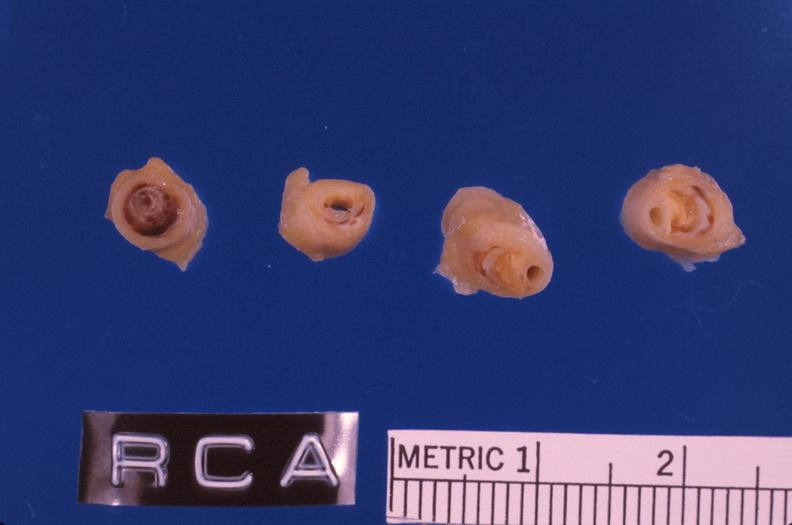s stillborn macerated present?
Answer the question using a single word or phrase. No 